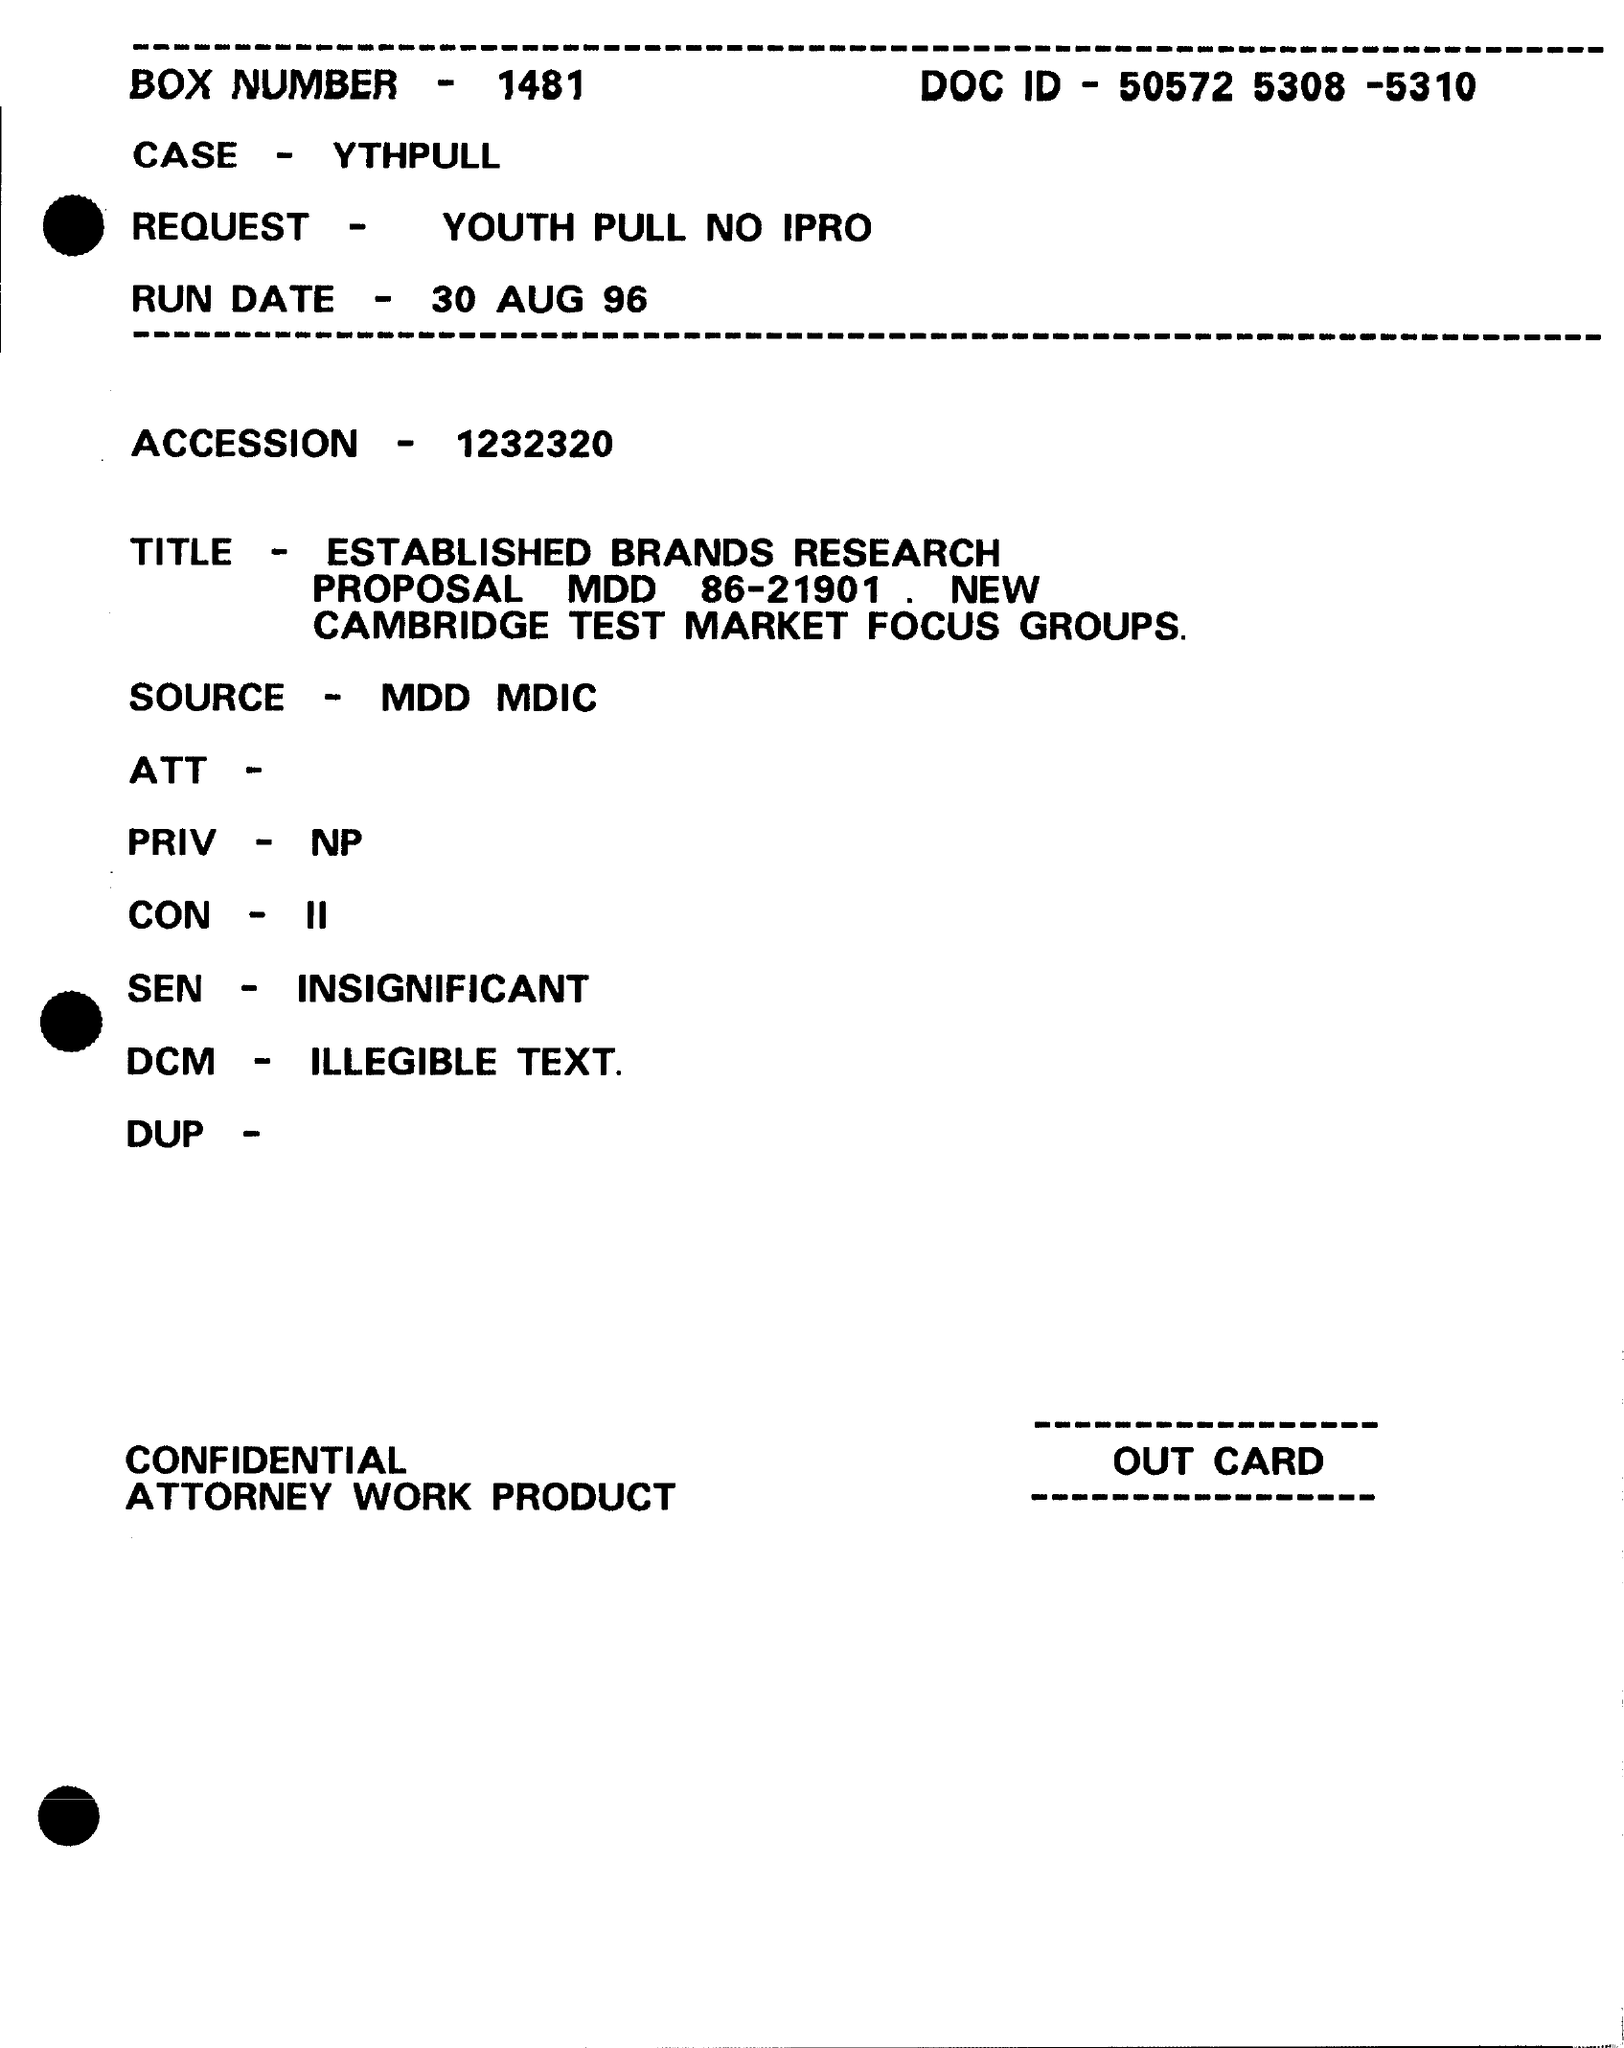What is the DOC ID?
Your answer should be very brief. 50572 5308 -5310. What is the BOX NUMBER?
Offer a terse response. 1481. What is the case specified?
Ensure brevity in your answer.  YTHPULL. What is the request?
Provide a succinct answer. YOUTH PULL NO IPRO. What is the run date?
Provide a short and direct response. 30 AUG 96. What is the number in ACCESSION field?
Your answer should be very brief. 1232320. 